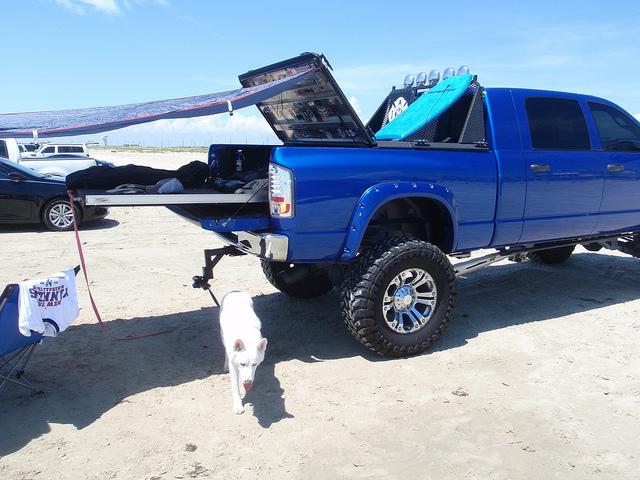What color is the truck?
Concise answer only. Blue. What kind of truck is this?
Quick response, please. Pick up truck. What animal is in the picture?
Keep it brief. Dog. 